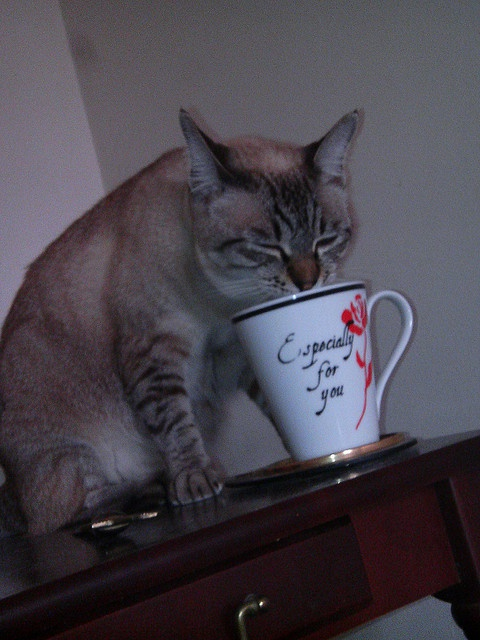Describe the objects in this image and their specific colors. I can see cat in gray, black, and purple tones and cup in gray and darkgray tones in this image. 